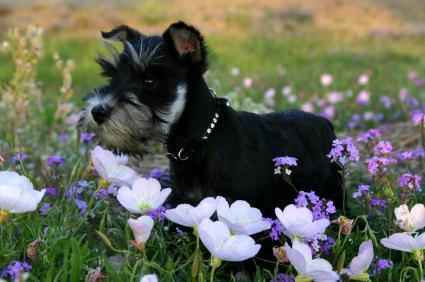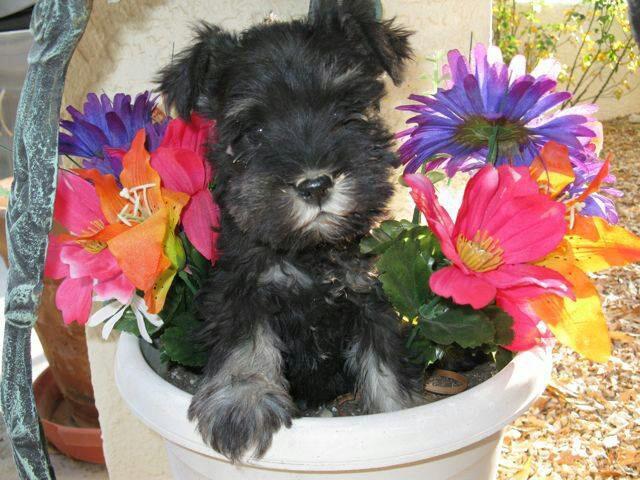The first image is the image on the left, the second image is the image on the right. Analyze the images presented: Is the assertion "An image contains at least three dogs." valid? Answer yes or no. No. The first image is the image on the left, the second image is the image on the right. For the images displayed, is the sentence "There are at most two dogs." factually correct? Answer yes or no. Yes. 